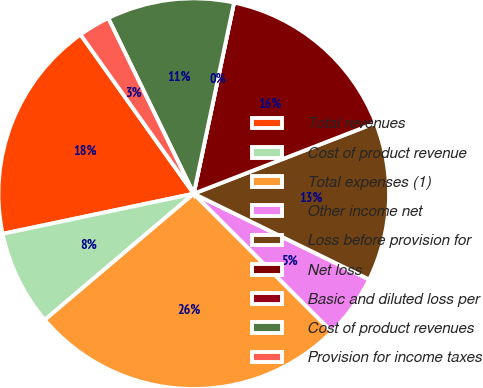Convert chart to OTSL. <chart><loc_0><loc_0><loc_500><loc_500><pie_chart><fcel>Total revenues<fcel>Cost of product revenue<fcel>Total expenses (1)<fcel>Other income net<fcel>Loss before provision for<fcel>Net loss<fcel>Basic and diluted loss per<fcel>Cost of product revenues<fcel>Provision for income taxes<nl><fcel>18.45%<fcel>7.89%<fcel>26.31%<fcel>5.26%<fcel>13.15%<fcel>15.78%<fcel>0.0%<fcel>10.52%<fcel>2.63%<nl></chart> 